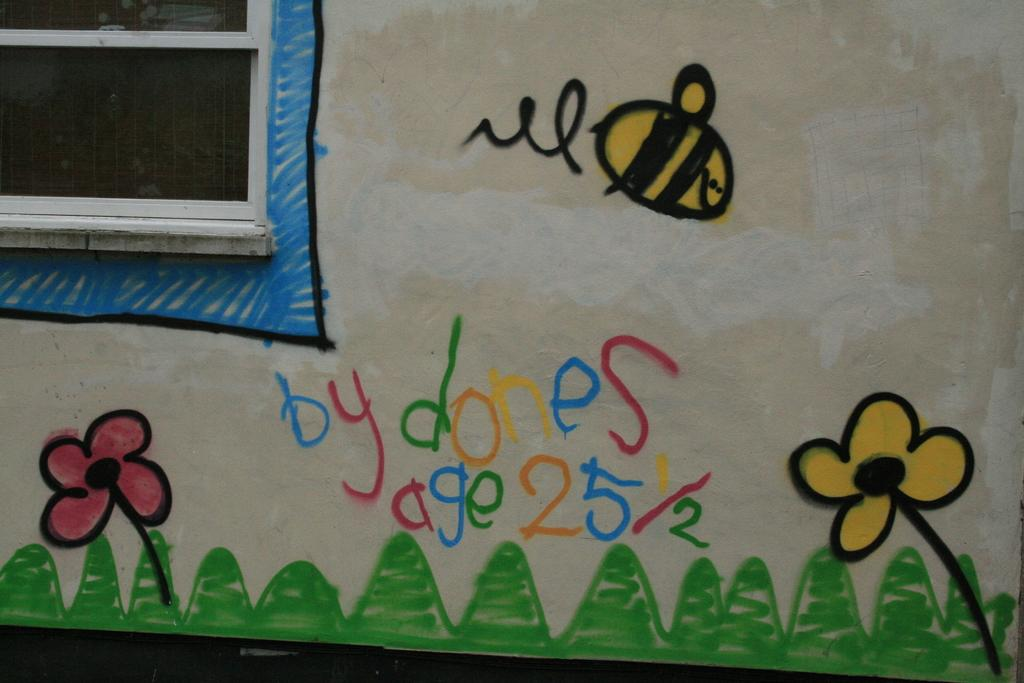What can be seen in the image that provides a view of the outdoors? There is a window in the image that provides a view of the outdoors. What type of artwork is present on the wall in the image? There is a painting on the wall in the image. How many ducks are visible in the painting on the wall? There is no mention of ducks in the image, as the painting on the wall is not described in detail. 